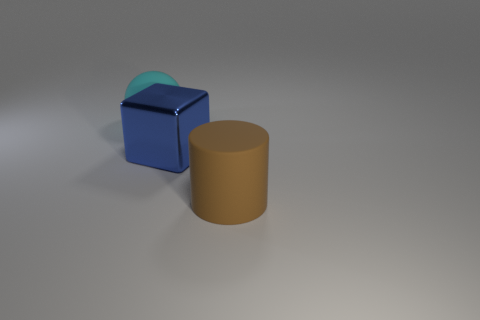Is there anything that points to the scale or possible usage of the objects? There's no definitive context in the image to ascertain the scale or specific use of the objects. They could be miniature models used for a display or regular-sized items meant for practical use. Without additional reference points or familiar objects to compare them with, it's challenging to determine their scale or purpose. 